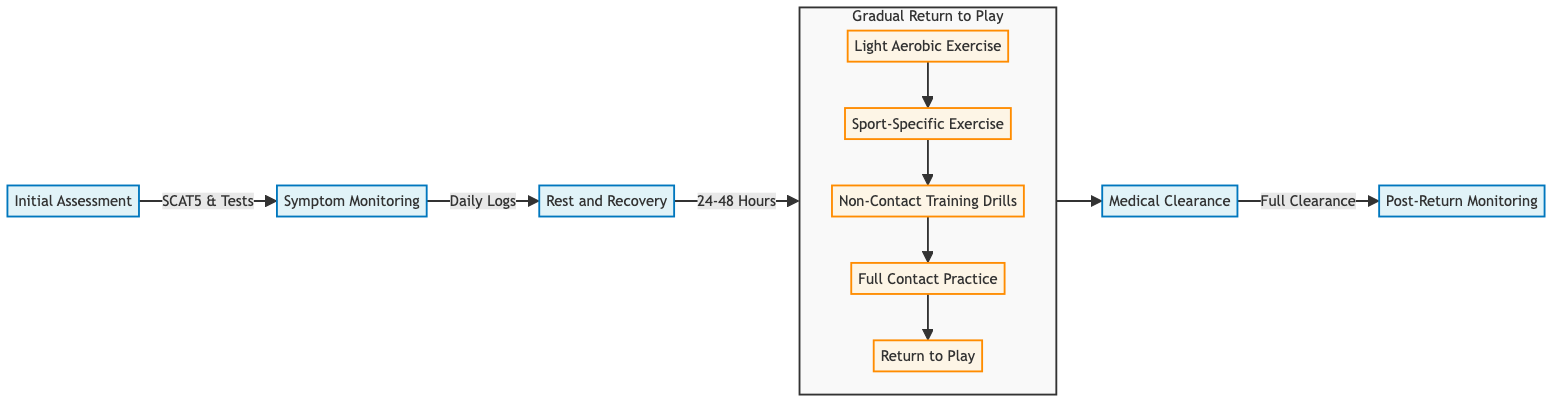What is the first step in the return-to-play decision-making process? The first step listed in the diagram is "Initial Assessment," which denotes the starting point of the process.
Answer: Initial Assessment How many stages are in the "Gradual Return to Play"? The diagram shows five stages under "Gradual Return to Play." They are Light Aerobic Exercise, Sport-Specific Exercise, Non-Contact Training Drills, Full Contact Practice, and Return to Play.
Answer: 5 What is the final step in the decision-making process? The final step in the flowchart is "Post-Return Monitoring," which indicates the last phase of the return-to-play process.
Answer: Post-Return Monitoring What is one criterion for the "Rest and Recovery" step? One of the criteria for "Rest and Recovery" is "Rest Period of 24-48 Hours," indicating the recommended duration of rest.
Answer: Rest Period of 24-48 Hours What must be completed before "Return to Play"? Before the step "Return to Play," the criteria needed include "Full Medical Clearance" and "Complete Symptom Resolution," which ensure readiness for competitive play.
Answer: Full Medical Clearance, Complete Symptom Resolution Describe the relationship between "Symptom Monitoring" and "Rest and Recovery". "Symptom Monitoring" directly leads to "Rest and Recovery," indicating that monitoring symptoms is a prerequisite for advising rest and recovery after initial assessment.
Answer: Leads to How does "Light Aerobic Exercise" initiate the return-to-play protocol? "Light Aerobic Exercise" is the first stage in the "Gradual Return to Play," designed to gradually increase activity levels after initial recovery, starting with minimal exertion.
Answer: First stage What is a necessary action during "Post-Return Monitoring"? A necessary action during "Post-Return Monitoring" is "Immediate Reporting of Any New Symptoms," ensuring that any recurrence of symptoms is quickly addressed.
Answer: Immediate Reporting of Any New Symptoms What is indicated by the direction of the arrows in the diagram? The arrows indicate the flow of the process, illustrating the sequence of steps from assessment to monitoring after return, showing how each step depends on the previous one.
Answer: Flow of the process 